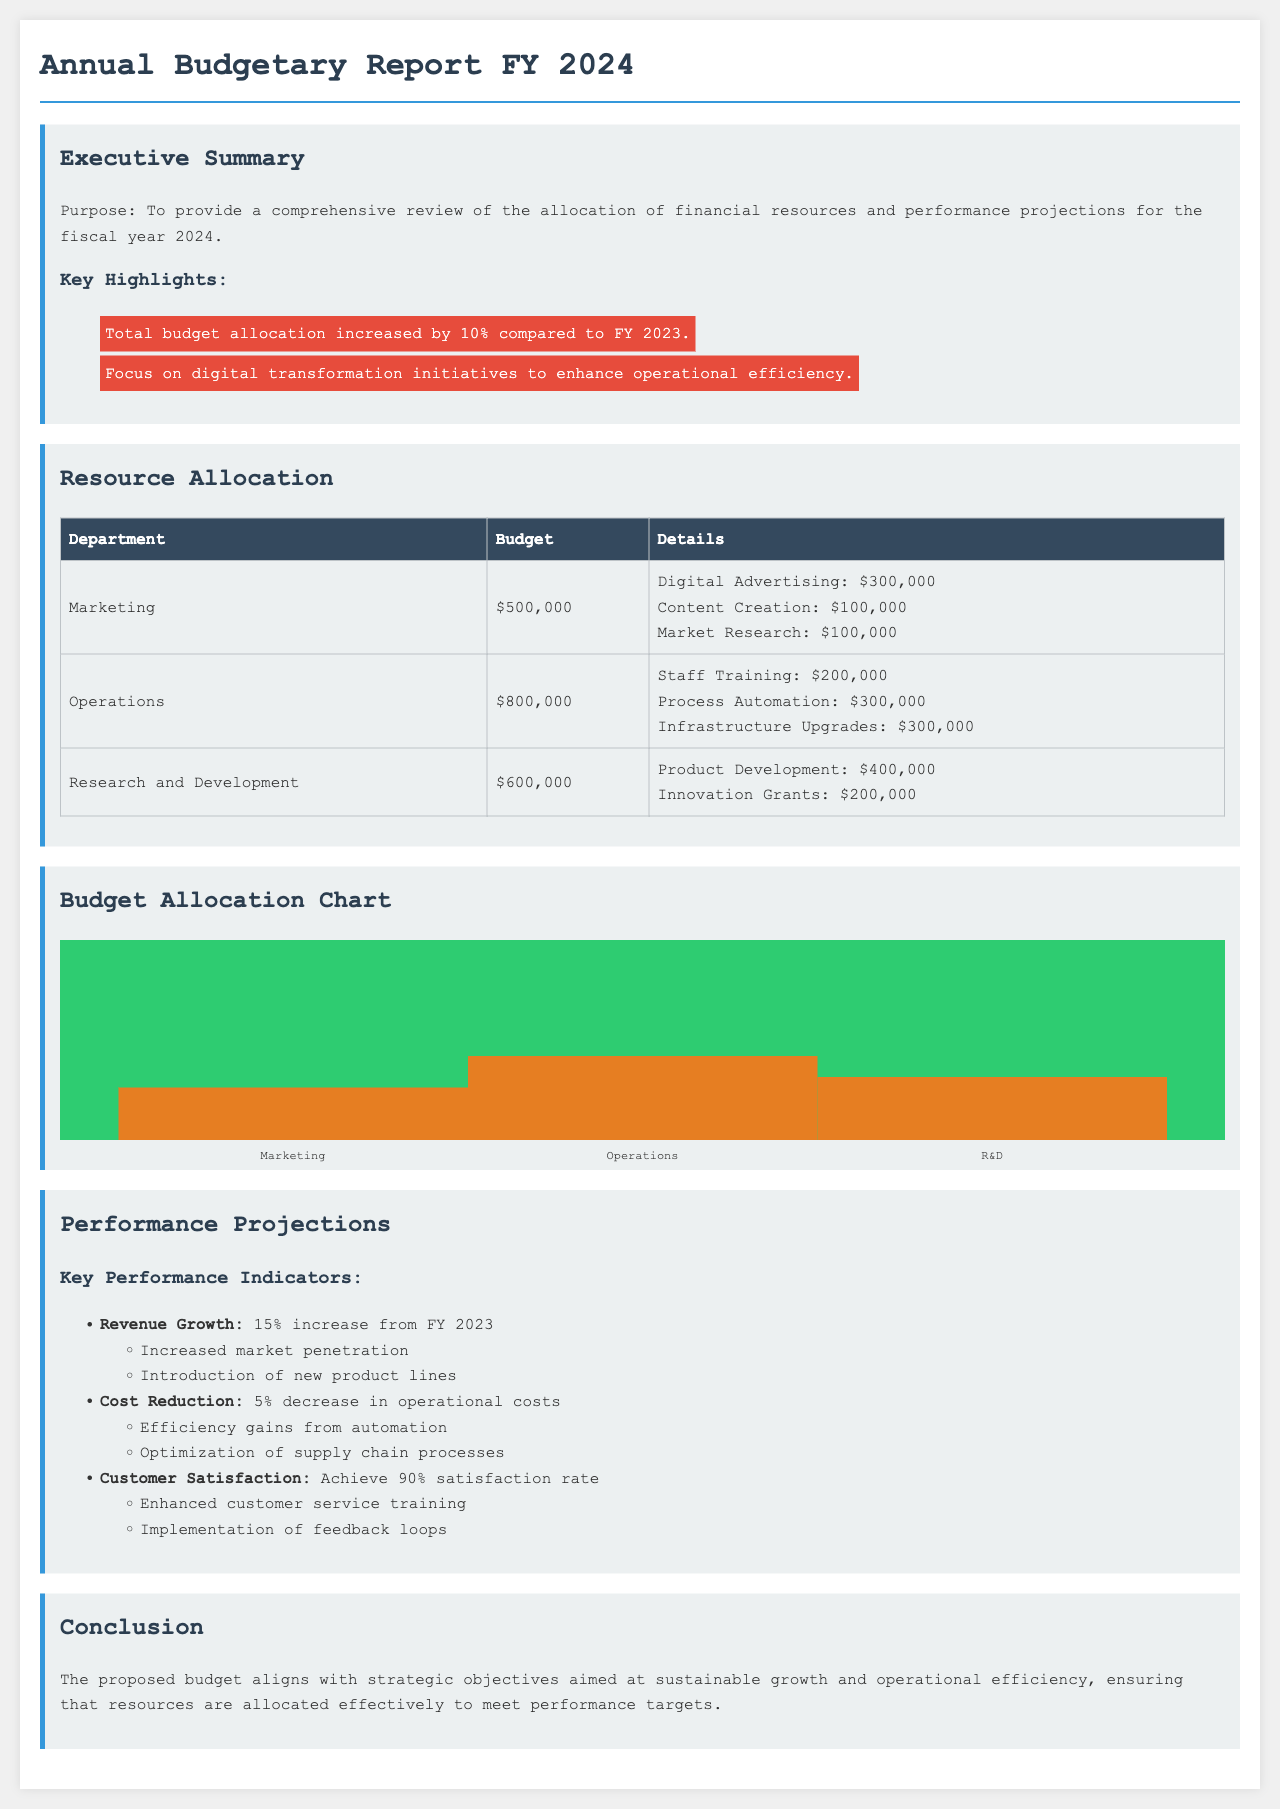What is the total budget allocation for FY 2024? The total budget allocation is the sum of all departmental budgets listed in the document, which is $500,000 + $800,000 + $600,000 = $1,900,000.
Answer: $1,900,000 What percentage increase does the budget allocation represent compared to FY 2023? The document states that the total budget allocation increased by 10% compared to FY 2023.
Answer: 10% What is the budget for the Operations department? The Operations department's budget is specified in the resource allocation section.
Answer: $800,000 Which department has the highest budget allocation? By comparing the departmental budgets in the table, Operations has the highest allocation.
Answer: Operations What is the projected revenue growth percentage for FY 2024? The performance projections indicate a planned revenue growth of 15% compared to FY 2023.
Answer: 15% What is the goal for customer satisfaction in FY 2024? The document specifies that the target is a customer satisfaction rate of 90%.
Answer: 90% How much budget is allocated for Staff Training in the Operations department? The detailed allocation for Operations indicates that $200,000 is earmarked for Staff Training.
Answer: $200,000 What are the innovation grants budgeted at for Research and Development? The budget details for R&D state that Innovation Grants are allocated $200,000.
Answer: $200,000 What is one focus area highlighted for the budget in FY 2024? The executive summary mentions digital transformation initiatives as a focus area for this budget.
Answer: Digital transformation initiatives 